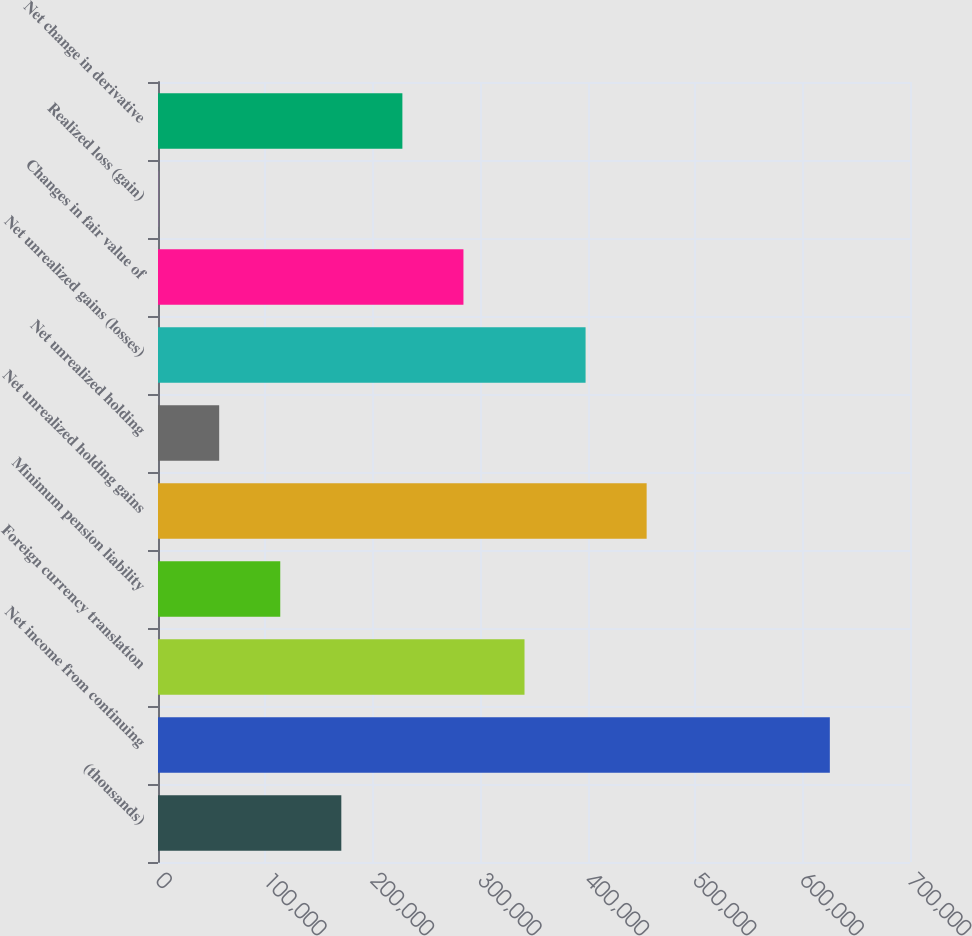Convert chart to OTSL. <chart><loc_0><loc_0><loc_500><loc_500><bar_chart><fcel>(thousands)<fcel>Net income from continuing<fcel>Foreign currency translation<fcel>Minimum pension liability<fcel>Net unrealized holding gains<fcel>Net unrealized holding<fcel>Net unrealized gains (losses)<fcel>Changes in fair value of<fcel>Realized loss (gain)<fcel>Net change in derivative<nl><fcel>170639<fcel>625382<fcel>341168<fcel>113797<fcel>454853<fcel>56953.8<fcel>398011<fcel>284325<fcel>111<fcel>227482<nl></chart> 